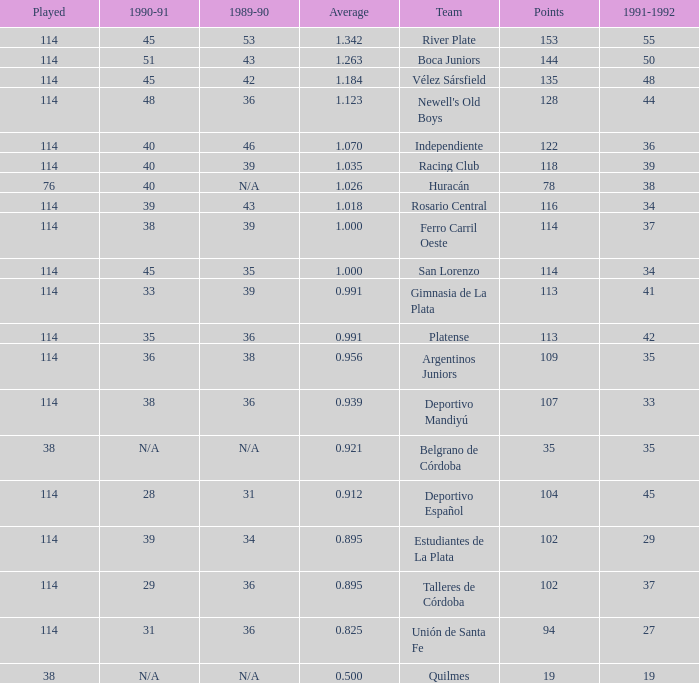How much Average has a 1989-90 of 36, and a Team of talleres de córdoba, and a Played smaller than 114? 0.0. 